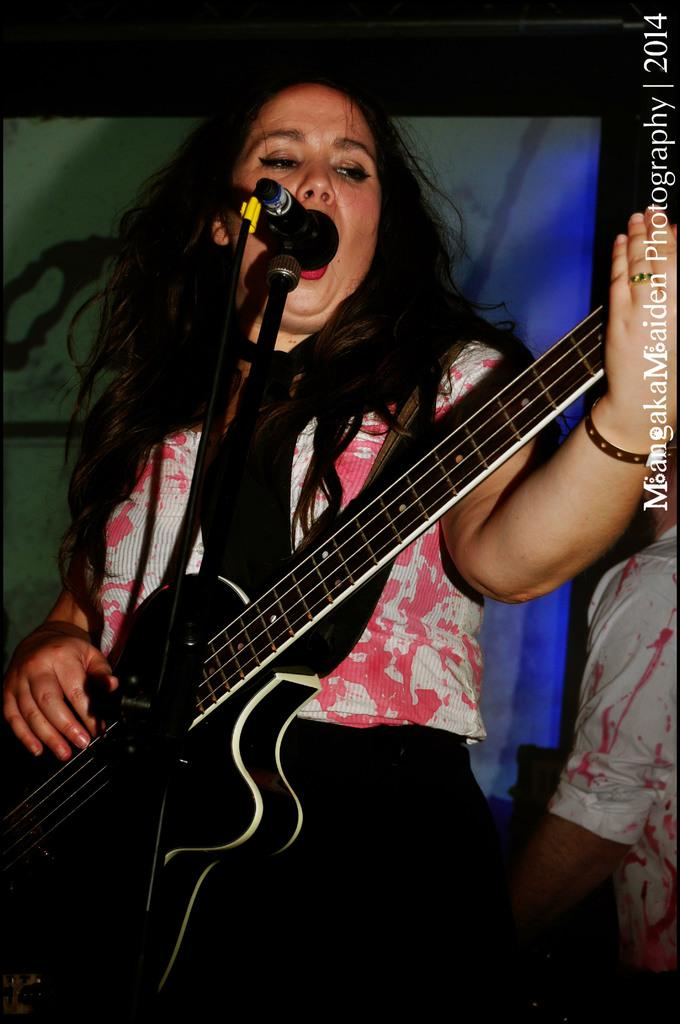What is the lady in the image doing? The lady is playing a guitar and singing. What object is in front of the lady? There is a microphone in front of the lady. What can be seen behind the lady? There is a poster behind the lady. Is there anyone else in the image besides the lady? Yes, there is a person standing on the right side of the image. What type of drug is on the shelf behind the lady? There is no shelf or drug present in the image. What is the lady using to pump air into the microphone? The lady is not using any device to pump air into the microphone; she is simply singing into it. 